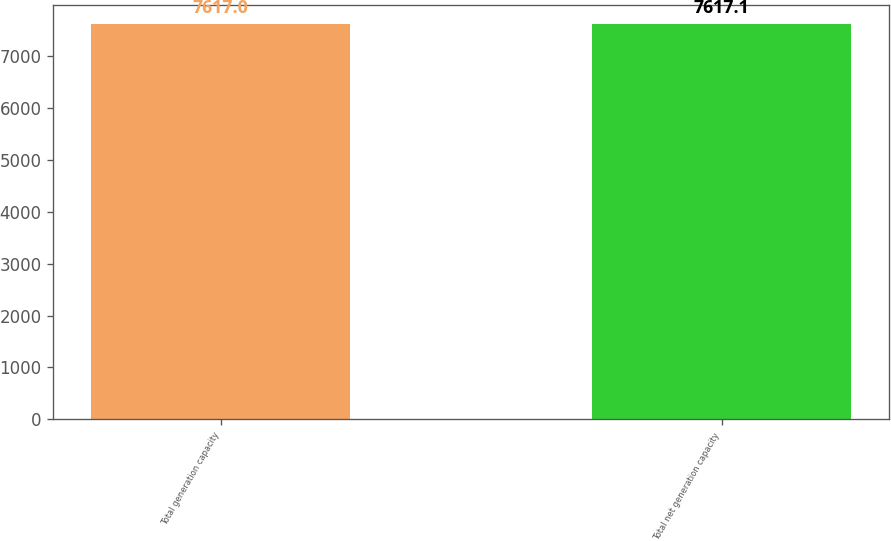Convert chart. <chart><loc_0><loc_0><loc_500><loc_500><bar_chart><fcel>Total generation capacity<fcel>Total net generation capacity<nl><fcel>7617<fcel>7617.1<nl></chart> 